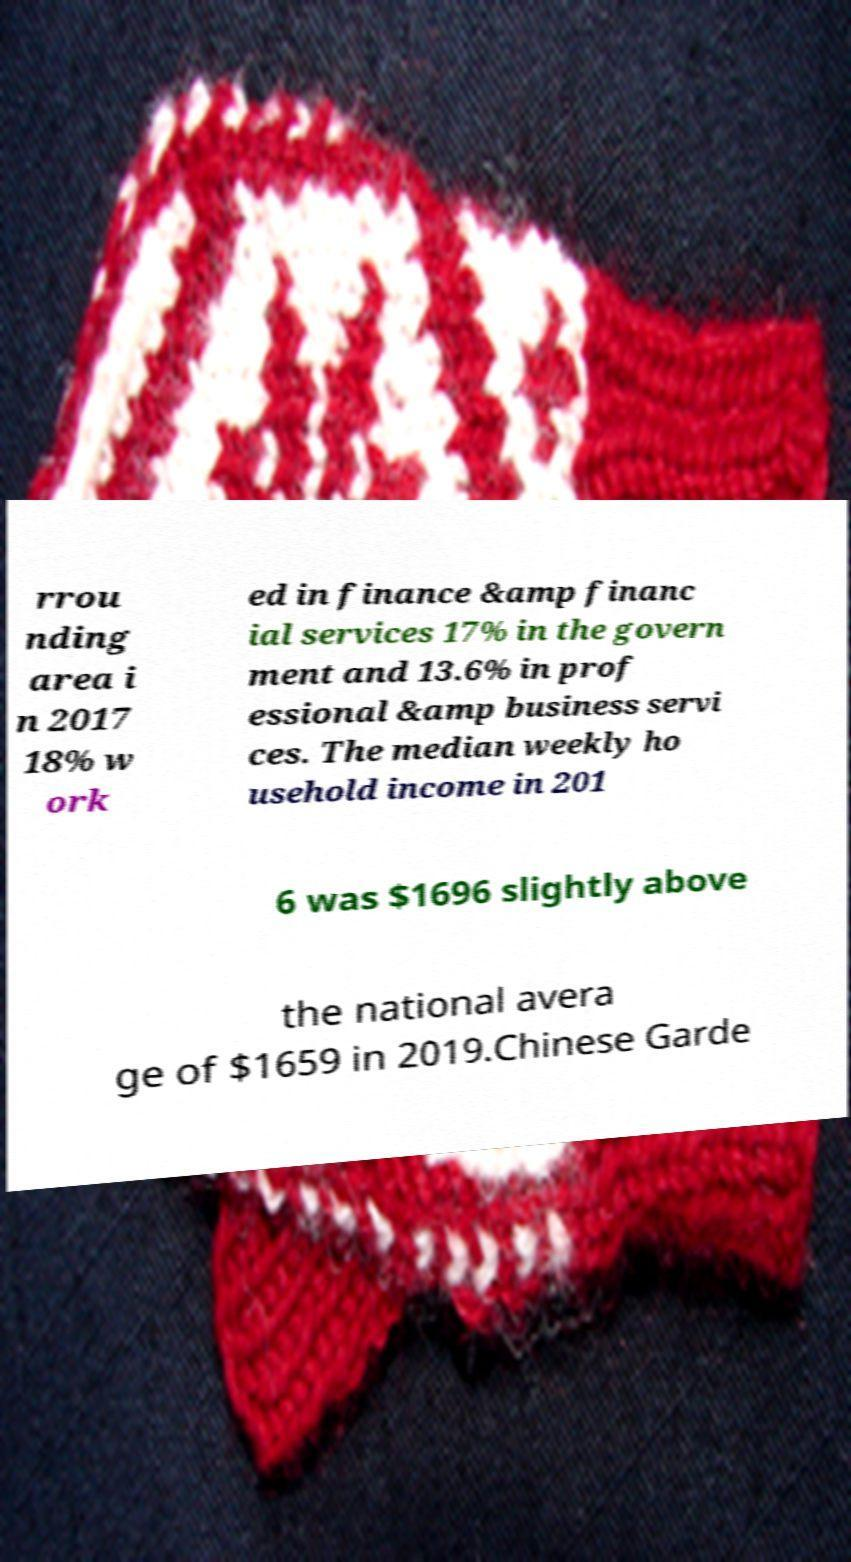Please read and relay the text visible in this image. What does it say? rrou nding area i n 2017 18% w ork ed in finance &amp financ ial services 17% in the govern ment and 13.6% in prof essional &amp business servi ces. The median weekly ho usehold income in 201 6 was $1696 slightly above the national avera ge of $1659 in 2019.Chinese Garde 